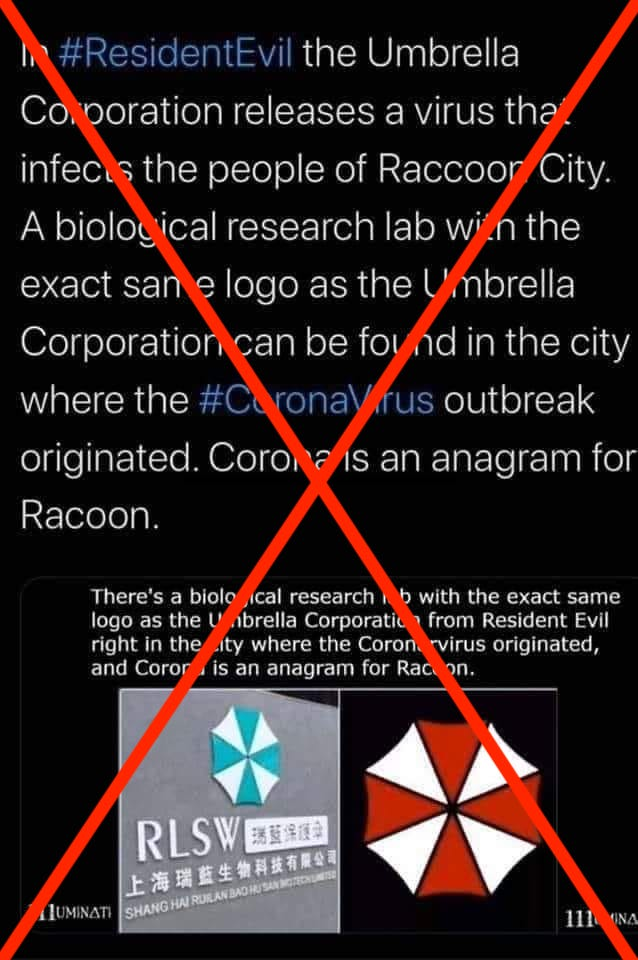A screenshot of a Facebook post about the coronavirus and a fictional lab from the 'Resident Evil' video game. We rate this claim False. Featured Fact-check Tweets stated on November 9, 2021 in a tweet 'Bill Gates just admitted that the Pfizer and Moderna mRNA vaccines don't work well.' By Samantha Putterman • November 17, 2021 The post was flagged as part of Facebook's efforts to combat false news and misinformation on its News Feed. (Read more about our partnership with Facebook.) Without getting too far into the details of 'Resident Evil,' it's clear that the post is inaccurate, as other fact-checkers have noted. In fact, the post gives itself away. Beneath the logo for the biological research lab identified in the image is the company's real name, Shang Hai Ruilan Bao Hu San Biotech Limited. The company does have a blue-and-white logo that closely resembles the red-and-white logo from the fictional lab in 'Resident Evil.' But according to the company's website, the lab is based in Shanghai, which is more than 500 miles by car away from Wuhan, per Google Maps. What's more, there's no evidence that the novel 2019 coronavirus was created in a lab. We've debunked a number of claims - like the Facebook post in question - that suggested the new virus was artificially made in Wuhan or elsewhere. According to the Centers for Disease Control and Prevention, the new coronavirus is a 'beta coronavirus' similar to severe acute respiratory syndrome, or SARS, and Middle East respiratory syndrome, or MERS. All three viruses are believed to have their origins in bats.

Read previous text and decide if "'In 'Resident Evil' the Umbrella Corporation releases a virus that infects the people of Raccoon City. A biological research lab with the exact same logo as the Umbrella Corporation can be found in the city where the coronavirus outbreak originated." is factually correct? 

Options: (a) no (b) not sure (c) yes Option (a) no.

The claim in the Facebook post is factually incorrect. The assertion that a biological research lab with the exact same logo as the fictional Umbrella Corporation from 'Resident Evil' is found in the city where the coronavirus outbreak originated is a baseless conspiracy theory. The Umbrella Corporation is a fictional entity, and any similarity to real-world logos is purely coincidental. Moreover, the real company, Shang Hai Ruilan Bao Hu San Biotech Limited, has a logo that, while superficially similar due to its radial design, is distinctly different in color and detail and has no connection to the game's narrative. Additionally, the assertion that "Coronavirus is an anagram for Racoon" is linguistically incorrect as the anagram does not match, and this statement seems to be included to create a sense of intrigue without basis in fact.

The broader claim that the coronavirus was released from a lab has been widely debunked by multiple fact-checking organizations and scientific studies. According to the Centers for Disease Control and Prevention (CDC), the coronavirus (SARS-CoV-2) is a beta coronavirus, like SARS and MERS, and all three are believed to have a zoonotic origin, particularly in bats, not a lab.

Therefore, the claim as stated in the social media post is not supported by any credible evidence and is rated as false. 